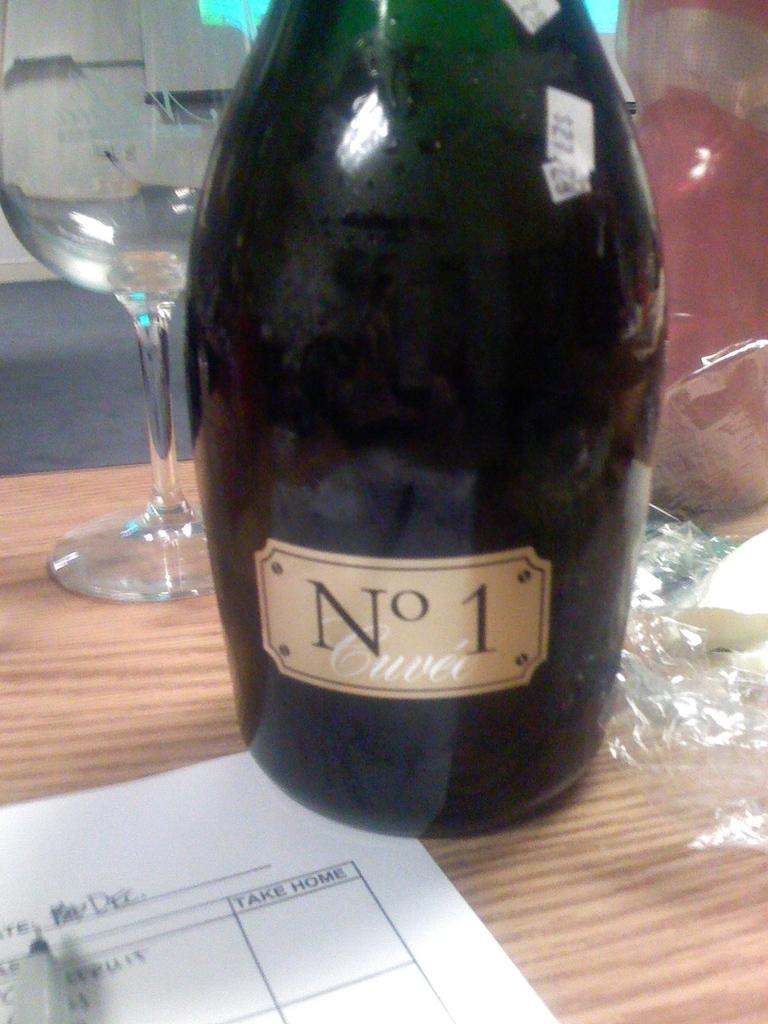What is the heading of the last column on the paper?
Your response must be concise. Take home. What is the name of the drink?
Make the answer very short. No 1. 